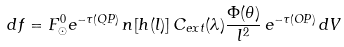<formula> <loc_0><loc_0><loc_500><loc_500>d f = F _ { \odot } ^ { 0 } e ^ { - \tau ( Q P ) } \, n [ h ( l ) ] \, C _ { e x t } ( \lambda ) \frac { \Phi ( \theta ) } { l ^ { 2 } } \, e ^ { - \tau ( O P ) } \, d V</formula> 